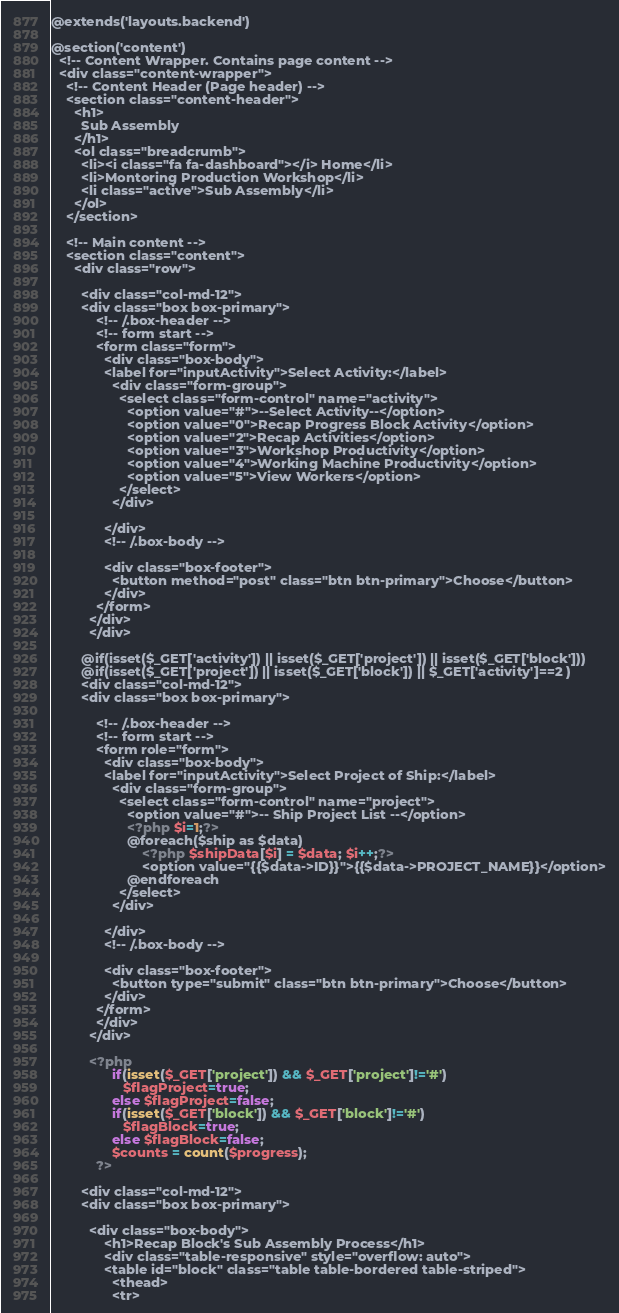Convert code to text. <code><loc_0><loc_0><loc_500><loc_500><_PHP_>@extends('layouts.backend')

@section('content')
  <!-- Content Wrapper. Contains page content -->
  <div class="content-wrapper">
    <!-- Content Header (Page header) -->
    <section class="content-header">
      <h1>
        Sub Assembly
      </h1>
      <ol class="breadcrumb">
        <li><i class="fa fa-dashboard"></i> Home</li>
        <li>Montoring Production Workshop</li>
        <li class="active">Sub Assembly</li>
      </ol>
    </section>

    <!-- Main content -->
    <section class="content">
      <div class="row">
        
        <div class="col-md-12">
        <div class="box box-primary">
            <!-- /.box-header -->
            <!-- form start -->
            <form class="form">
              <div class="box-body">
              <label for="inputActivity">Select Activity:</label>
                <div class="form-group">
                  <select class="form-control" name="activity">
                    <option value="#">--Select Activity--</option>
                    <option value="0">Recap Progress Block Activity</option>
                    <option value="2">Recap Activities</option>
                    <option value="3">Workshop Productivity</option>
                    <option value="4">Working Machine Productivity</option>
                    <option value="5">View Workers</option>
                  </select>
                </div>
               
              </div>
              <!-- /.box-body -->

              <div class="box-footer">
                <button method="post" class="btn btn-primary">Choose</button>
              </div>
            </form>
          </div>
          </div>

        @if(isset($_GET['activity']) || isset($_GET['project']) || isset($_GET['block']))
        @if(isset($_GET['project']) || isset($_GET['block']) || $_GET['activity']==2 )
        <div class="col-md-12">
        <div class="box box-primary">
            
            <!-- /.box-header -->
            <!-- form start -->
            <form role="form">
              <div class="box-body">
              <label for="inputActivity">Select Project of Ship:</label>
                <div class="form-group">
                  <select class="form-control" name="project">
                    <option value="#">-- Ship Project List --</option>
                    <?php $i=1;?>
                    @foreach($ship as $data)
                        <?php $shipData[$i] = $data; $i++;?>
                        <option value="{{$data->ID}}">{{$data->PROJECT_NAME}}</option>
                    @endforeach
                  </select>
                </div>
               
              </div>
              <!-- /.box-body -->

              <div class="box-footer">
                <button type="submit" class="btn btn-primary">Choose</button>
              </div>
            </form>
            </div>
          </div>

          <?php 
                if(isset($_GET['project']) && $_GET['project']!='#') 
                   $flagProject=true;
                else $flagProject=false;
                if(isset($_GET['block']) && $_GET['block']!='#') 
                   $flagBlock=true;
                else $flagBlock=false;
                $counts = count($progress);
            ?>
        
        <div class="col-md-12">
        <div class="box box-primary">
            
          <div class="box-body">
              <h1>Recap Block's Sub Assembly Process</h1>
              <div class="table-responsive" style="overflow: auto">
              <table id="block" class="table table-bordered table-striped">
                <thead>
                <tr></code> 